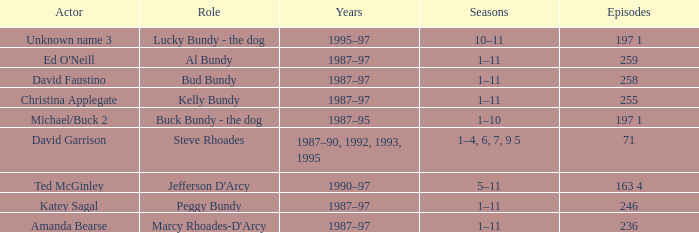How many episodes did the actor David Faustino appear in? 258.0. 